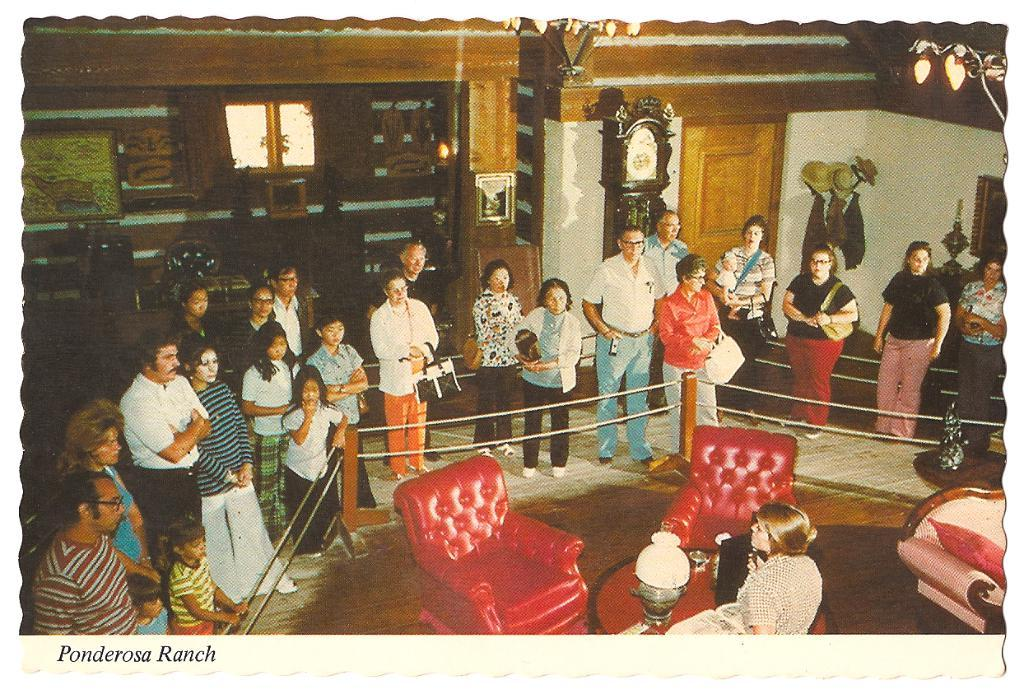<image>
Provide a brief description of the given image. A large group of men and women are standing around looking at the Ponderosa Ranch. 